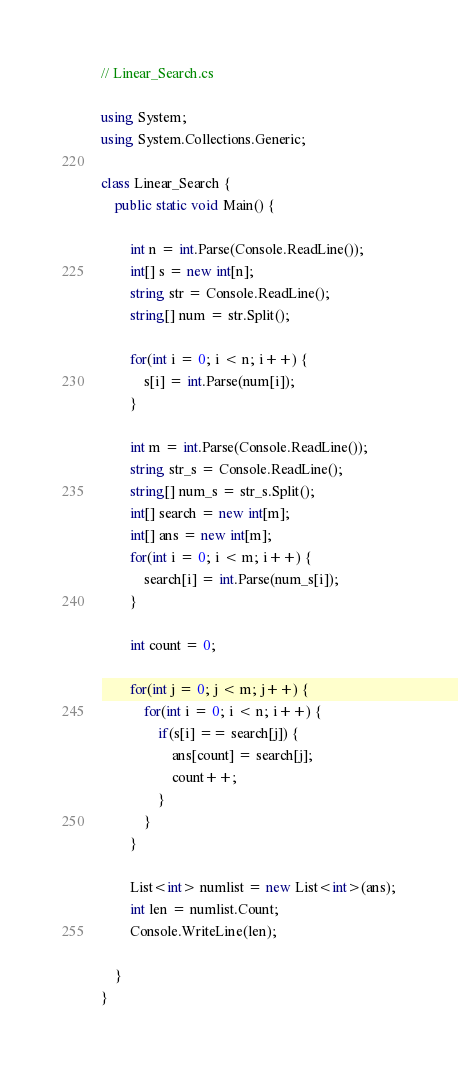Convert code to text. <code><loc_0><loc_0><loc_500><loc_500><_C#_>// Linear_Search.cs

using System;
using System.Collections.Generic;

class Linear_Search {
	public static void Main() {

		int n = int.Parse(Console.ReadLine());
		int[] s = new int[n];
		string str = Console.ReadLine();
		string[] num = str.Split();

		for(int i = 0; i < n; i++) {
			s[i] = int.Parse(num[i]);
		}

		int m = int.Parse(Console.ReadLine());
		string str_s = Console.ReadLine();
		string[] num_s = str_s.Split();
		int[] search = new int[m];
		int[] ans = new int[m];
		for(int i = 0; i < m; i++) {
			search[i] = int.Parse(num_s[i]);
		}

		int count = 0;

		for(int j = 0; j < m; j++) {
			for(int i = 0; i < n; i++) {
				if(s[i] == search[j]) {
					ans[count] = search[j];
					count++;
				}
			}
		}

		List<int> numlist = new List<int>(ans);
		int len = numlist.Count;
		Console.WriteLine(len);

	}
}</code> 